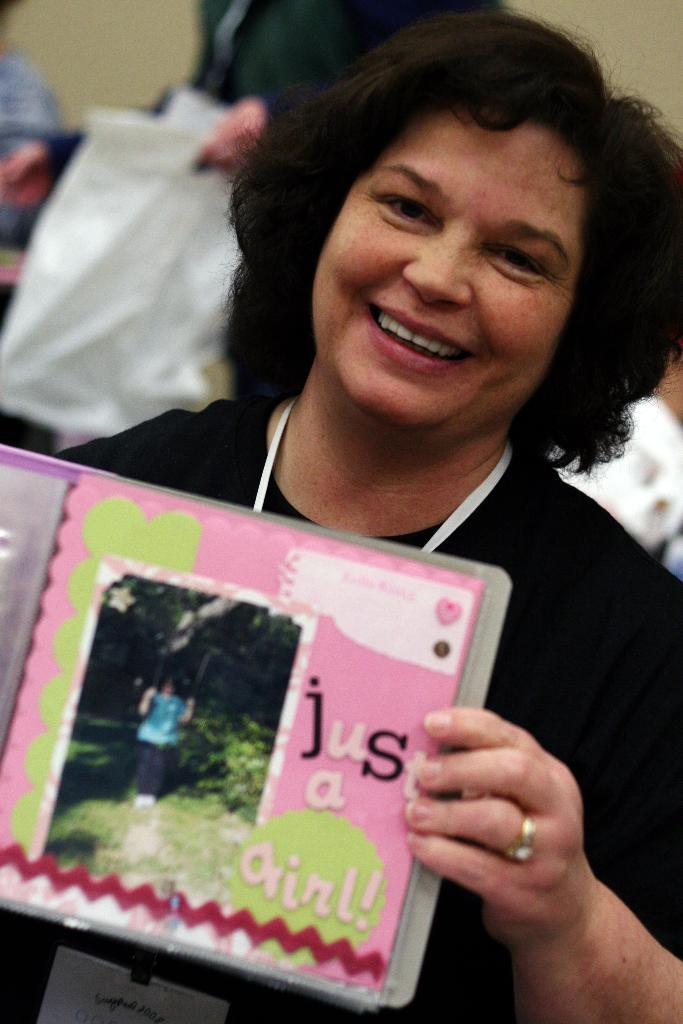Who is the main subject in the image? There is a woman in the image. Where is the woman positioned in the image? The woman is standing in the middle of the image. What is the woman holding in the image? The woman is holding a book. What is the woman's facial expression in the image? The woman is smiling. Can you describe the people behind the woman in the image? The people behind the woman are holding papers. What type of van can be seen in the image? There is no van present in the image. What is the temperature like in the image? The image does not provide information about the temperature. 